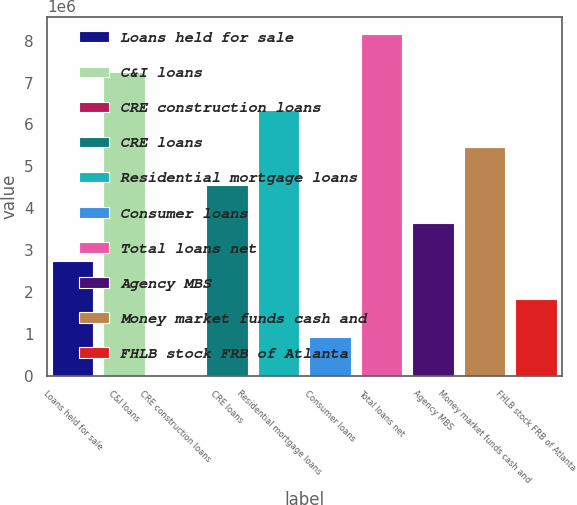Convert chart to OTSL. <chart><loc_0><loc_0><loc_500><loc_500><bar_chart><fcel>Loans held for sale<fcel>C&I loans<fcel>CRE construction loans<fcel>CRE loans<fcel>Residential mortgage loans<fcel>Consumer loans<fcel>Total loans net<fcel>Agency MBS<fcel>Money market funds cash and<fcel>FHLB stock FRB of Atlanta<nl><fcel>2.73311e+06<fcel>7.26111e+06<fcel>16314<fcel>4.54431e+06<fcel>6.35551e+06<fcel>921914<fcel>8.16671e+06<fcel>3.63871e+06<fcel>5.44991e+06<fcel>1.82751e+06<nl></chart> 